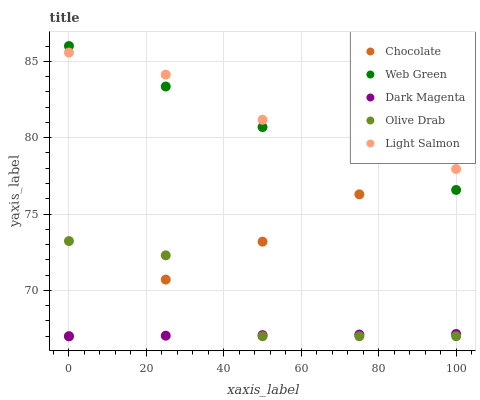Does Dark Magenta have the minimum area under the curve?
Answer yes or no. Yes. Does Light Salmon have the maximum area under the curve?
Answer yes or no. Yes. Does Light Salmon have the minimum area under the curve?
Answer yes or no. No. Does Dark Magenta have the maximum area under the curve?
Answer yes or no. No. Is Dark Magenta the smoothest?
Answer yes or no. Yes. Is Olive Drab the roughest?
Answer yes or no. Yes. Is Light Salmon the smoothest?
Answer yes or no. No. Is Light Salmon the roughest?
Answer yes or no. No. Does Olive Drab have the lowest value?
Answer yes or no. Yes. Does Light Salmon have the lowest value?
Answer yes or no. No. Does Web Green have the highest value?
Answer yes or no. Yes. Does Light Salmon have the highest value?
Answer yes or no. No. Is Dark Magenta less than Light Salmon?
Answer yes or no. Yes. Is Web Green greater than Dark Magenta?
Answer yes or no. Yes. Does Chocolate intersect Web Green?
Answer yes or no. Yes. Is Chocolate less than Web Green?
Answer yes or no. No. Is Chocolate greater than Web Green?
Answer yes or no. No. Does Dark Magenta intersect Light Salmon?
Answer yes or no. No. 